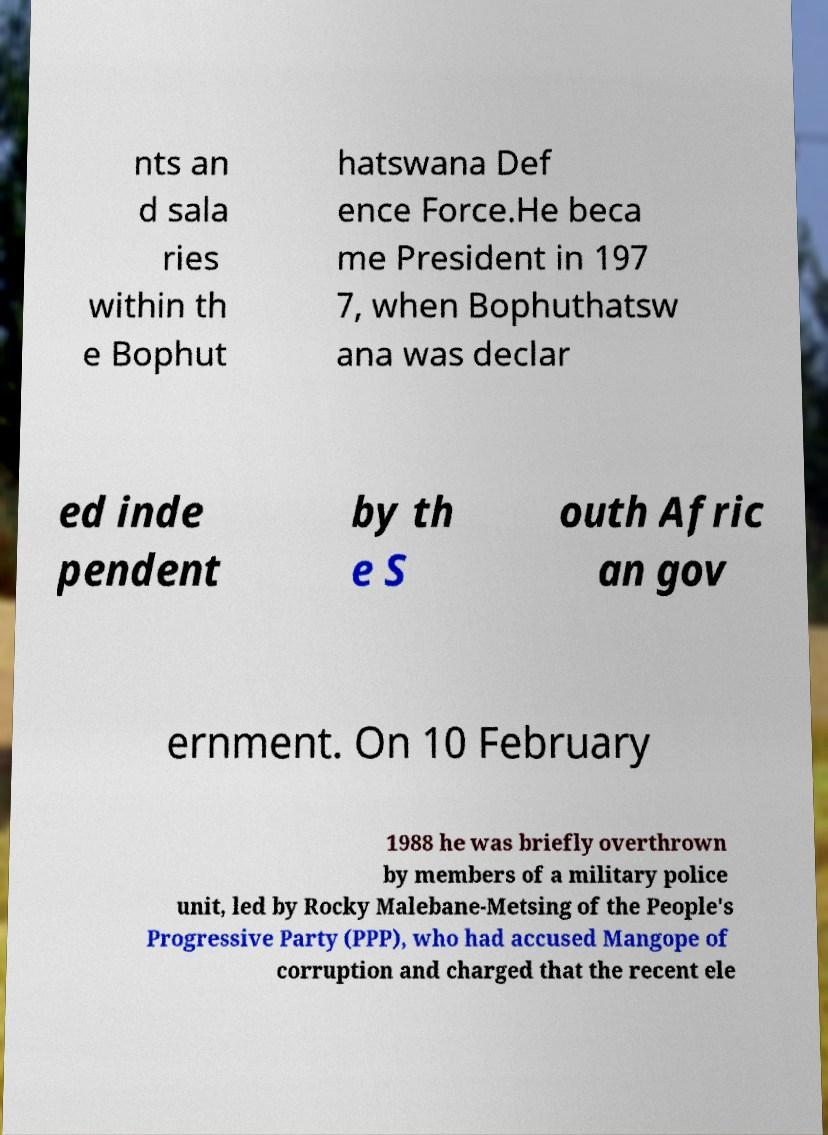Could you extract and type out the text from this image? nts an d sala ries within th e Bophut hatswana Def ence Force.He beca me President in 197 7, when Bophuthatsw ana was declar ed inde pendent by th e S outh Afric an gov ernment. On 10 February 1988 he was briefly overthrown by members of a military police unit, led by Rocky Malebane-Metsing of the People's Progressive Party (PPP), who had accused Mangope of corruption and charged that the recent ele 